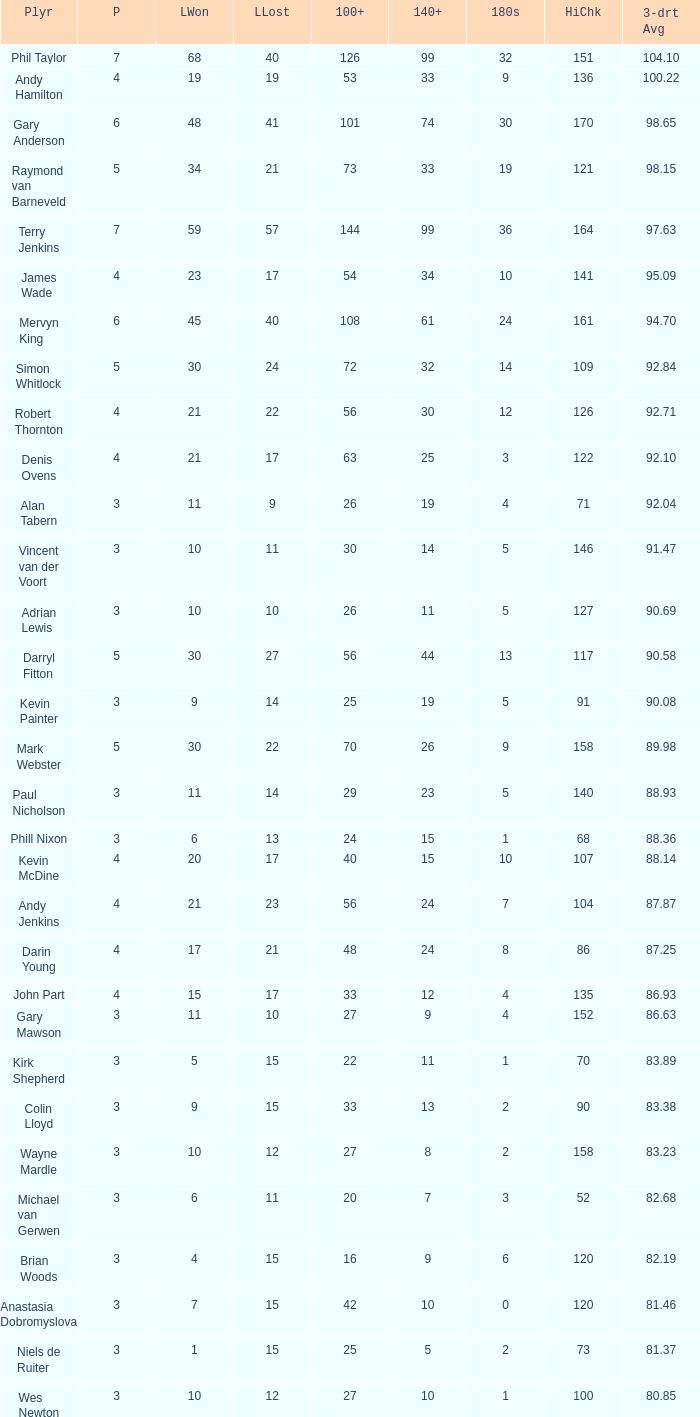Who is the player with 41 legs lost? Gary Anderson. 